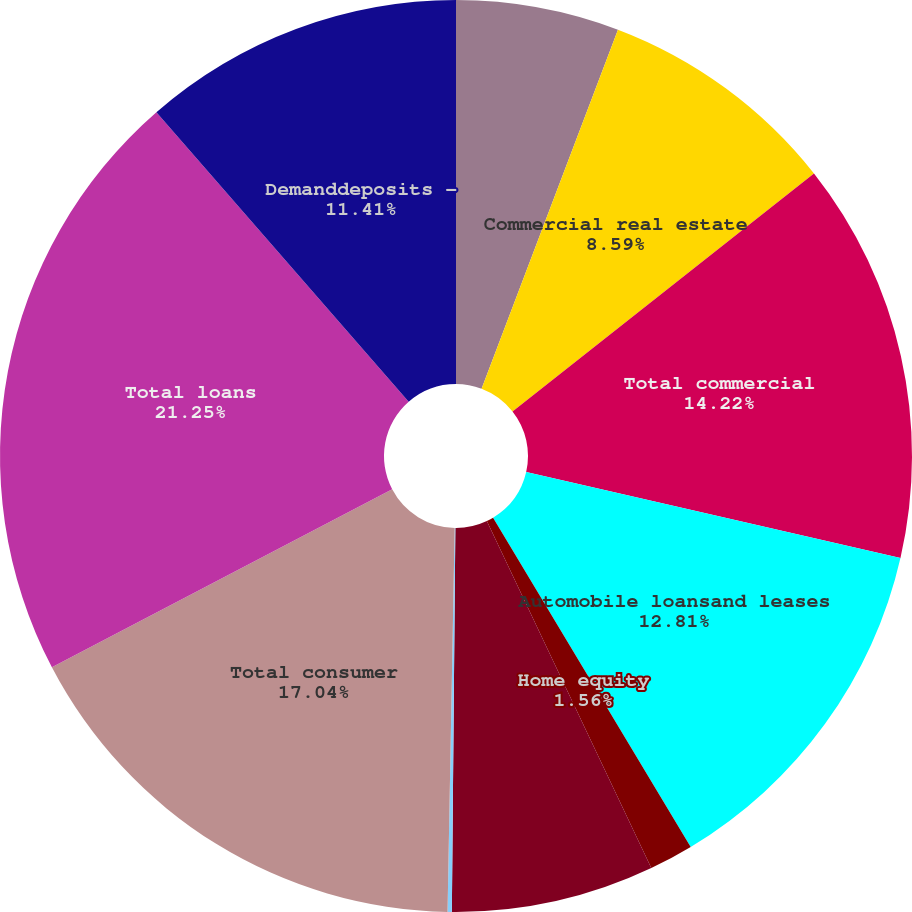Convert chart. <chart><loc_0><loc_0><loc_500><loc_500><pie_chart><fcel>Commercial and industrial<fcel>Commercial real estate<fcel>Total commercial<fcel>Automobile loansand leases<fcel>Home equity<fcel>Residential mortgage<fcel>Other consumer<fcel>Total consumer<fcel>Total loans<fcel>Demanddeposits -<nl><fcel>5.78%<fcel>8.59%<fcel>14.22%<fcel>12.81%<fcel>1.56%<fcel>7.19%<fcel>0.15%<fcel>17.04%<fcel>21.26%<fcel>11.41%<nl></chart> 